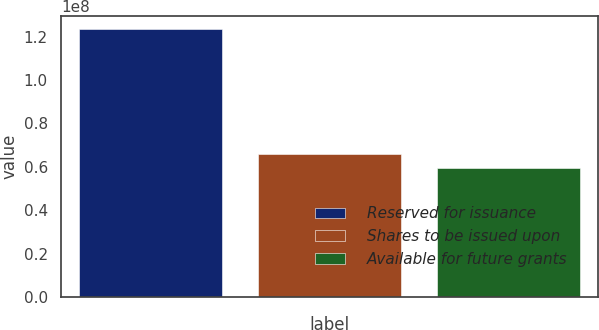Convert chart to OTSL. <chart><loc_0><loc_0><loc_500><loc_500><bar_chart><fcel>Reserved for issuance<fcel>Shares to be issued upon<fcel>Available for future grants<nl><fcel>1.23297e+08<fcel>6.59531e+07<fcel>5.95816e+07<nl></chart> 